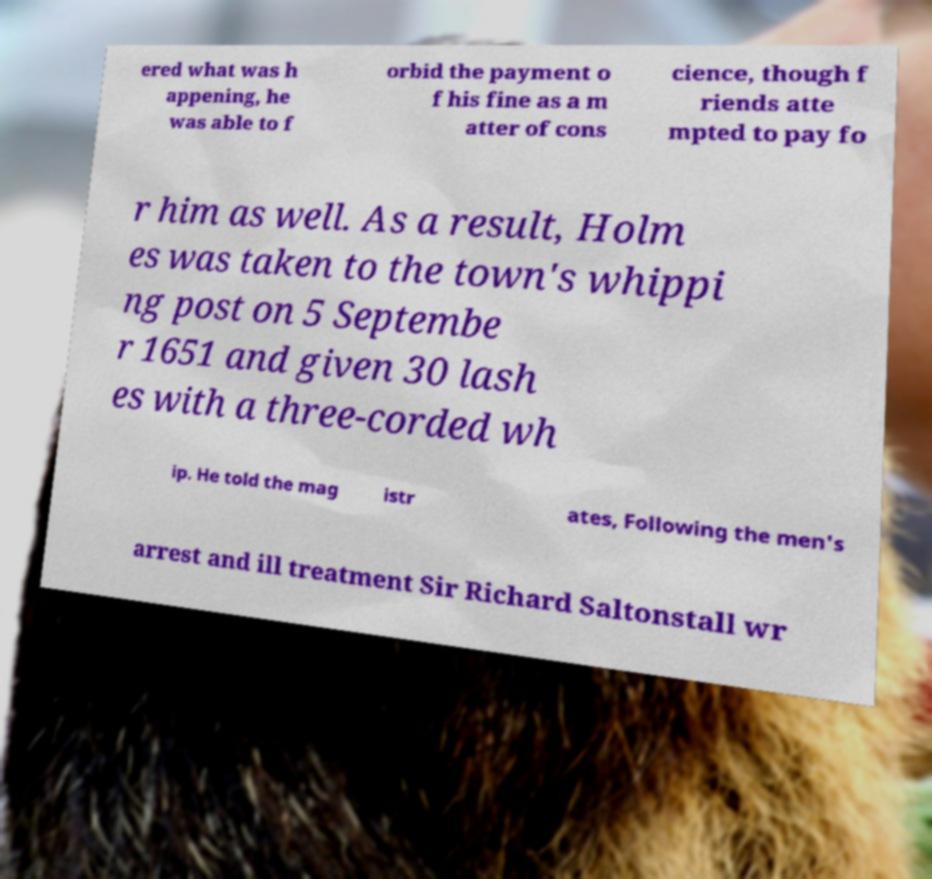Could you assist in decoding the text presented in this image and type it out clearly? ered what was h appening, he was able to f orbid the payment o f his fine as a m atter of cons cience, though f riends atte mpted to pay fo r him as well. As a result, Holm es was taken to the town's whippi ng post on 5 Septembe r 1651 and given 30 lash es with a three-corded wh ip. He told the mag istr ates, Following the men's arrest and ill treatment Sir Richard Saltonstall wr 